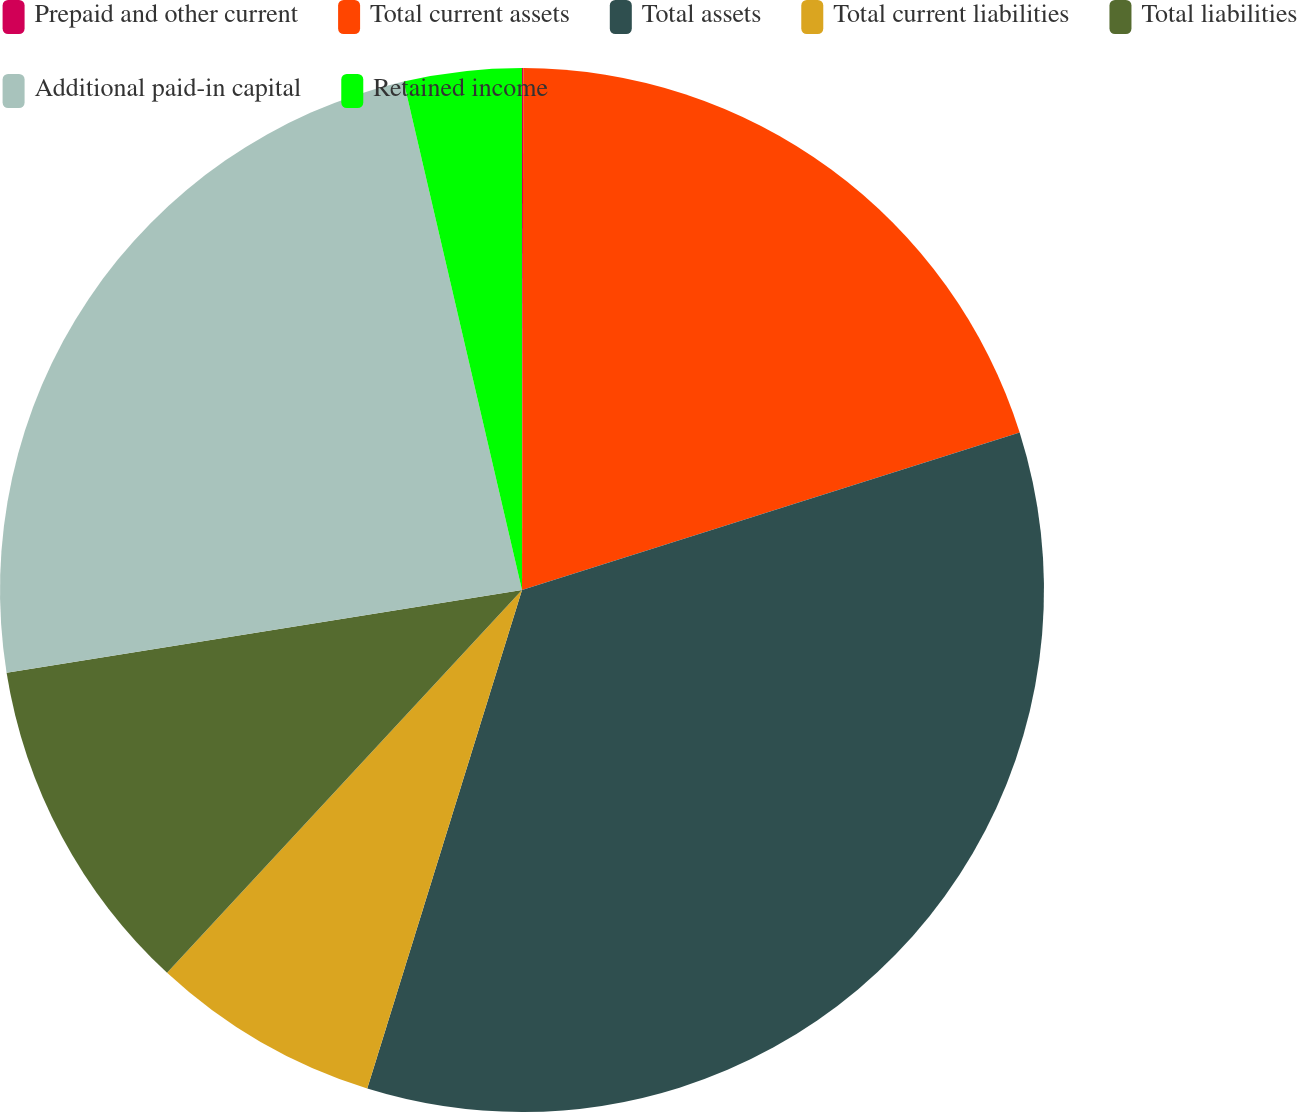Convert chart. <chart><loc_0><loc_0><loc_500><loc_500><pie_chart><fcel>Prepaid and other current<fcel>Total current assets<fcel>Total assets<fcel>Total current liabilities<fcel>Total liabilities<fcel>Additional paid-in capital<fcel>Retained income<nl><fcel>0.04%<fcel>20.08%<fcel>34.67%<fcel>7.11%<fcel>10.57%<fcel>23.89%<fcel>3.64%<nl></chart> 